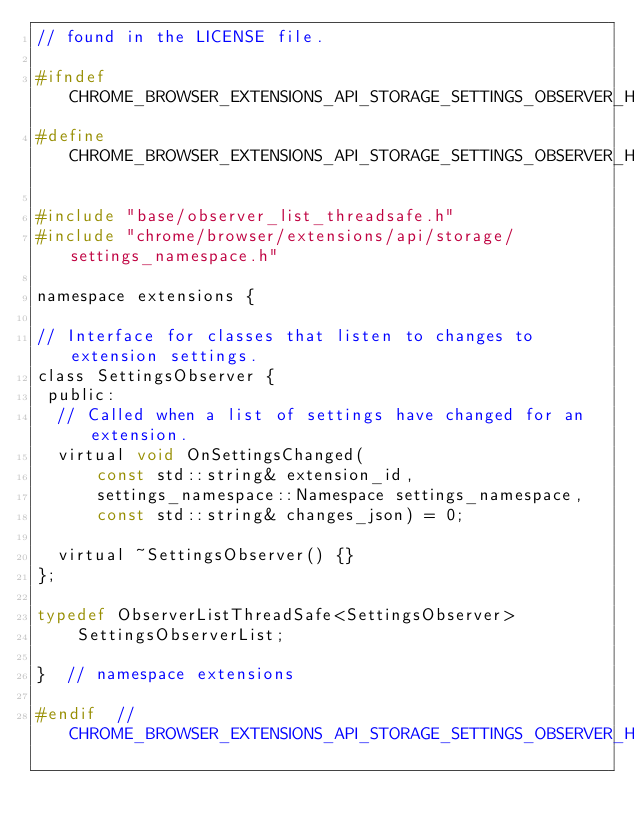Convert code to text. <code><loc_0><loc_0><loc_500><loc_500><_C_>// found in the LICENSE file.

#ifndef CHROME_BROWSER_EXTENSIONS_API_STORAGE_SETTINGS_OBSERVER_H_
#define CHROME_BROWSER_EXTENSIONS_API_STORAGE_SETTINGS_OBSERVER_H_

#include "base/observer_list_threadsafe.h"
#include "chrome/browser/extensions/api/storage/settings_namespace.h"

namespace extensions {

// Interface for classes that listen to changes to extension settings.
class SettingsObserver {
 public:
  // Called when a list of settings have changed for an extension.
  virtual void OnSettingsChanged(
      const std::string& extension_id,
      settings_namespace::Namespace settings_namespace,
      const std::string& changes_json) = 0;

  virtual ~SettingsObserver() {}
};

typedef ObserverListThreadSafe<SettingsObserver>
    SettingsObserverList;

}  // namespace extensions

#endif  // CHROME_BROWSER_EXTENSIONS_API_STORAGE_SETTINGS_OBSERVER_H_
</code> 